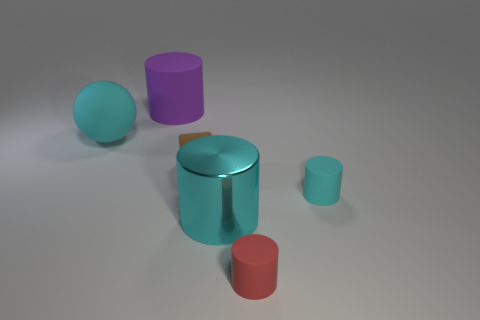Subtract all small cyan cylinders. How many cylinders are left? 3 Add 3 purple matte objects. How many objects exist? 9 Subtract all spheres. How many objects are left? 5 Subtract all purple cylinders. How many cylinders are left? 3 Subtract all big shiny things. Subtract all small cubes. How many objects are left? 4 Add 3 cyan things. How many cyan things are left? 6 Add 2 cyan metal cylinders. How many cyan metal cylinders exist? 3 Subtract 0 green spheres. How many objects are left? 6 Subtract all red blocks. Subtract all gray cylinders. How many blocks are left? 1 Subtract all green spheres. How many cyan cylinders are left? 2 